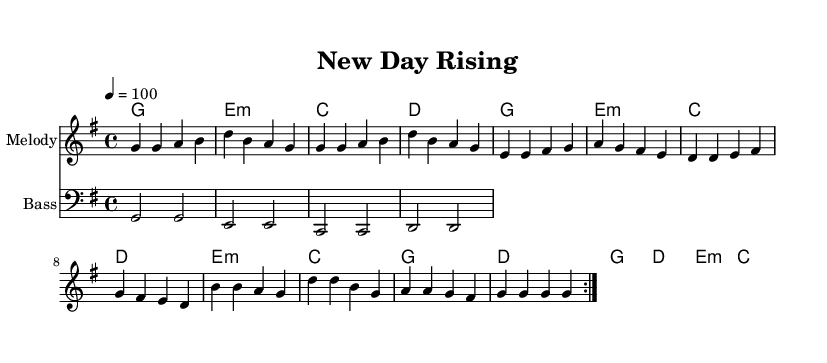What is the key signature of this music? The key signature is G major, which has one sharp, F#. This can be determined by looking at the key signature at the beginning of the piece, which indicates G major is being used.
Answer: G major What is the time signature of the piece? The time signature is 4/4. This is indicated at the beginning of the staff, where the symbols show that there are four beats in a measure and a quarter note receives one beat.
Answer: 4/4 What is the tempo marking of this music? The tempo marking is 100 beats per minute. This is specified at the beginning of the score, letting musicians know the speed at which to play the piece.
Answer: 100 How many measures are included in the melody? There are 16 measures in the melody part. This can be counted by looking at the repeated volta marking and counting each measure in the repeated sections.
Answer: 16 What is the first chord in the harmonies section? The first chord is G major. This can be identified from the chord symbols listed in the first measure of the harmonies, where G major is notated.
Answer: G What indicates that the melody should be played with a repeated section? The repeat volta sign indicates that the section should be played twice. This is seen in the score where there are markings like "volta" indicating the structure for repetitions.
Answer: Volta How do the chords reflect the theme of freedom in the piece? The chords use a progression that creates a sense of uplifting spirit and resolution, typical in feel-good R&B music that celebrates themes like freedom and second chances. This reasoning comes from analyzing common chord progressions in music that evoke positive emotions.
Answer: Uplifting progression 